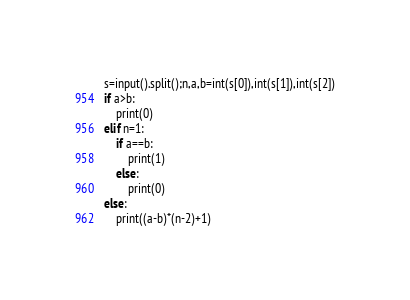<code> <loc_0><loc_0><loc_500><loc_500><_Python_>s=input().split();n,a,b=int(s[0]),int(s[1]),int(s[2])
if a>b:
    print(0)
elif n=1:
    if a==b:
        print(1)
    else:
        print(0)
else:
    print((a-b)*(n-2)+1)</code> 